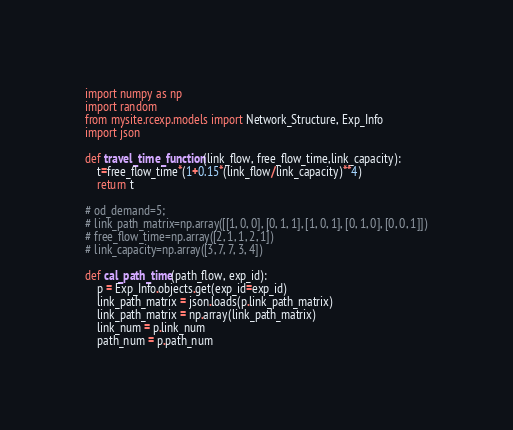<code> <loc_0><loc_0><loc_500><loc_500><_Python_>import numpy as np
import random
from mysite.rcexp.models import Network_Structure, Exp_Info
import json

def travel_time_function(link_flow, free_flow_time,link_capacity):
	t=free_flow_time*(1+0.15*(link_flow/link_capacity)**4)
	return t

# od_demand=5;
# link_path_matrix=np.array([[1, 0, 0], [0, 1, 1], [1, 0, 1], [0, 1, 0], [0, 0, 1]])
# free_flow_time=np.array([2, 1, 1, 2, 1])
# link_capacity=np.array([3, 7, 7, 3, 4])

def cal_path_time(path_flow, exp_id):
	p = Exp_Info.objects.get(exp_id=exp_id)
	link_path_matrix = json.loads(p.link_path_matrix)
	link_path_matrix = np.array(link_path_matrix)
	link_num = p.link_num
	path_num = p.path_num</code> 